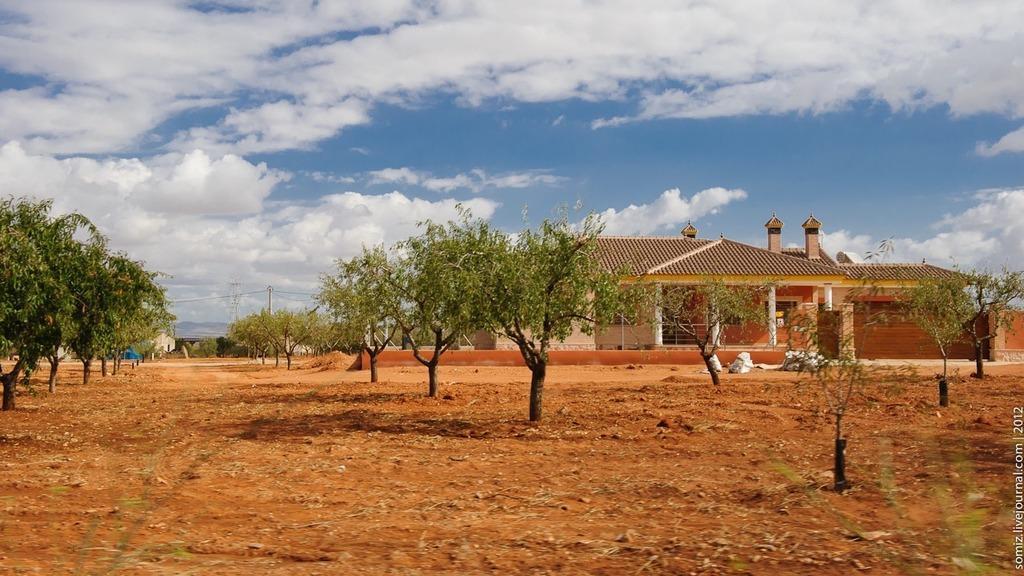In one or two sentences, can you explain what this image depicts? In this image I can see the ground, few trees, a house and few poles. In the background I can see the sky. 